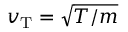Convert formula to latex. <formula><loc_0><loc_0><loc_500><loc_500>v _ { T } = \sqrt { T / m }</formula> 